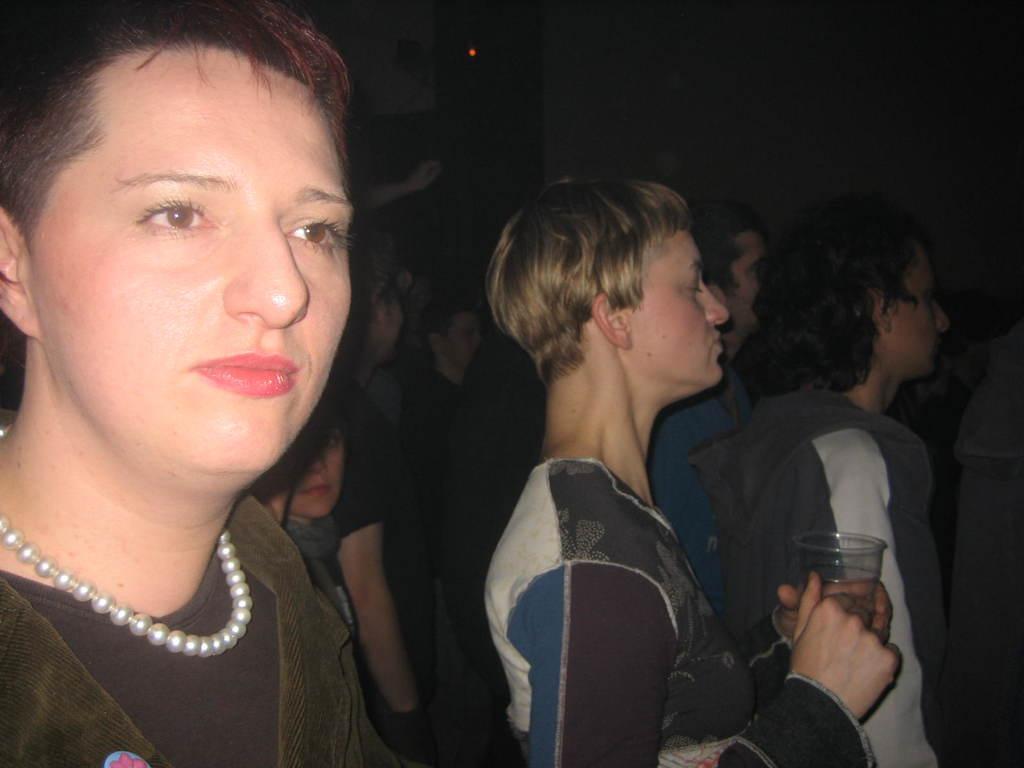Describe this image in one or two sentences. In this picture there is a person standing and holding the glass and there are group of people standing. At the back there is a wall and there is a device on the wall. 